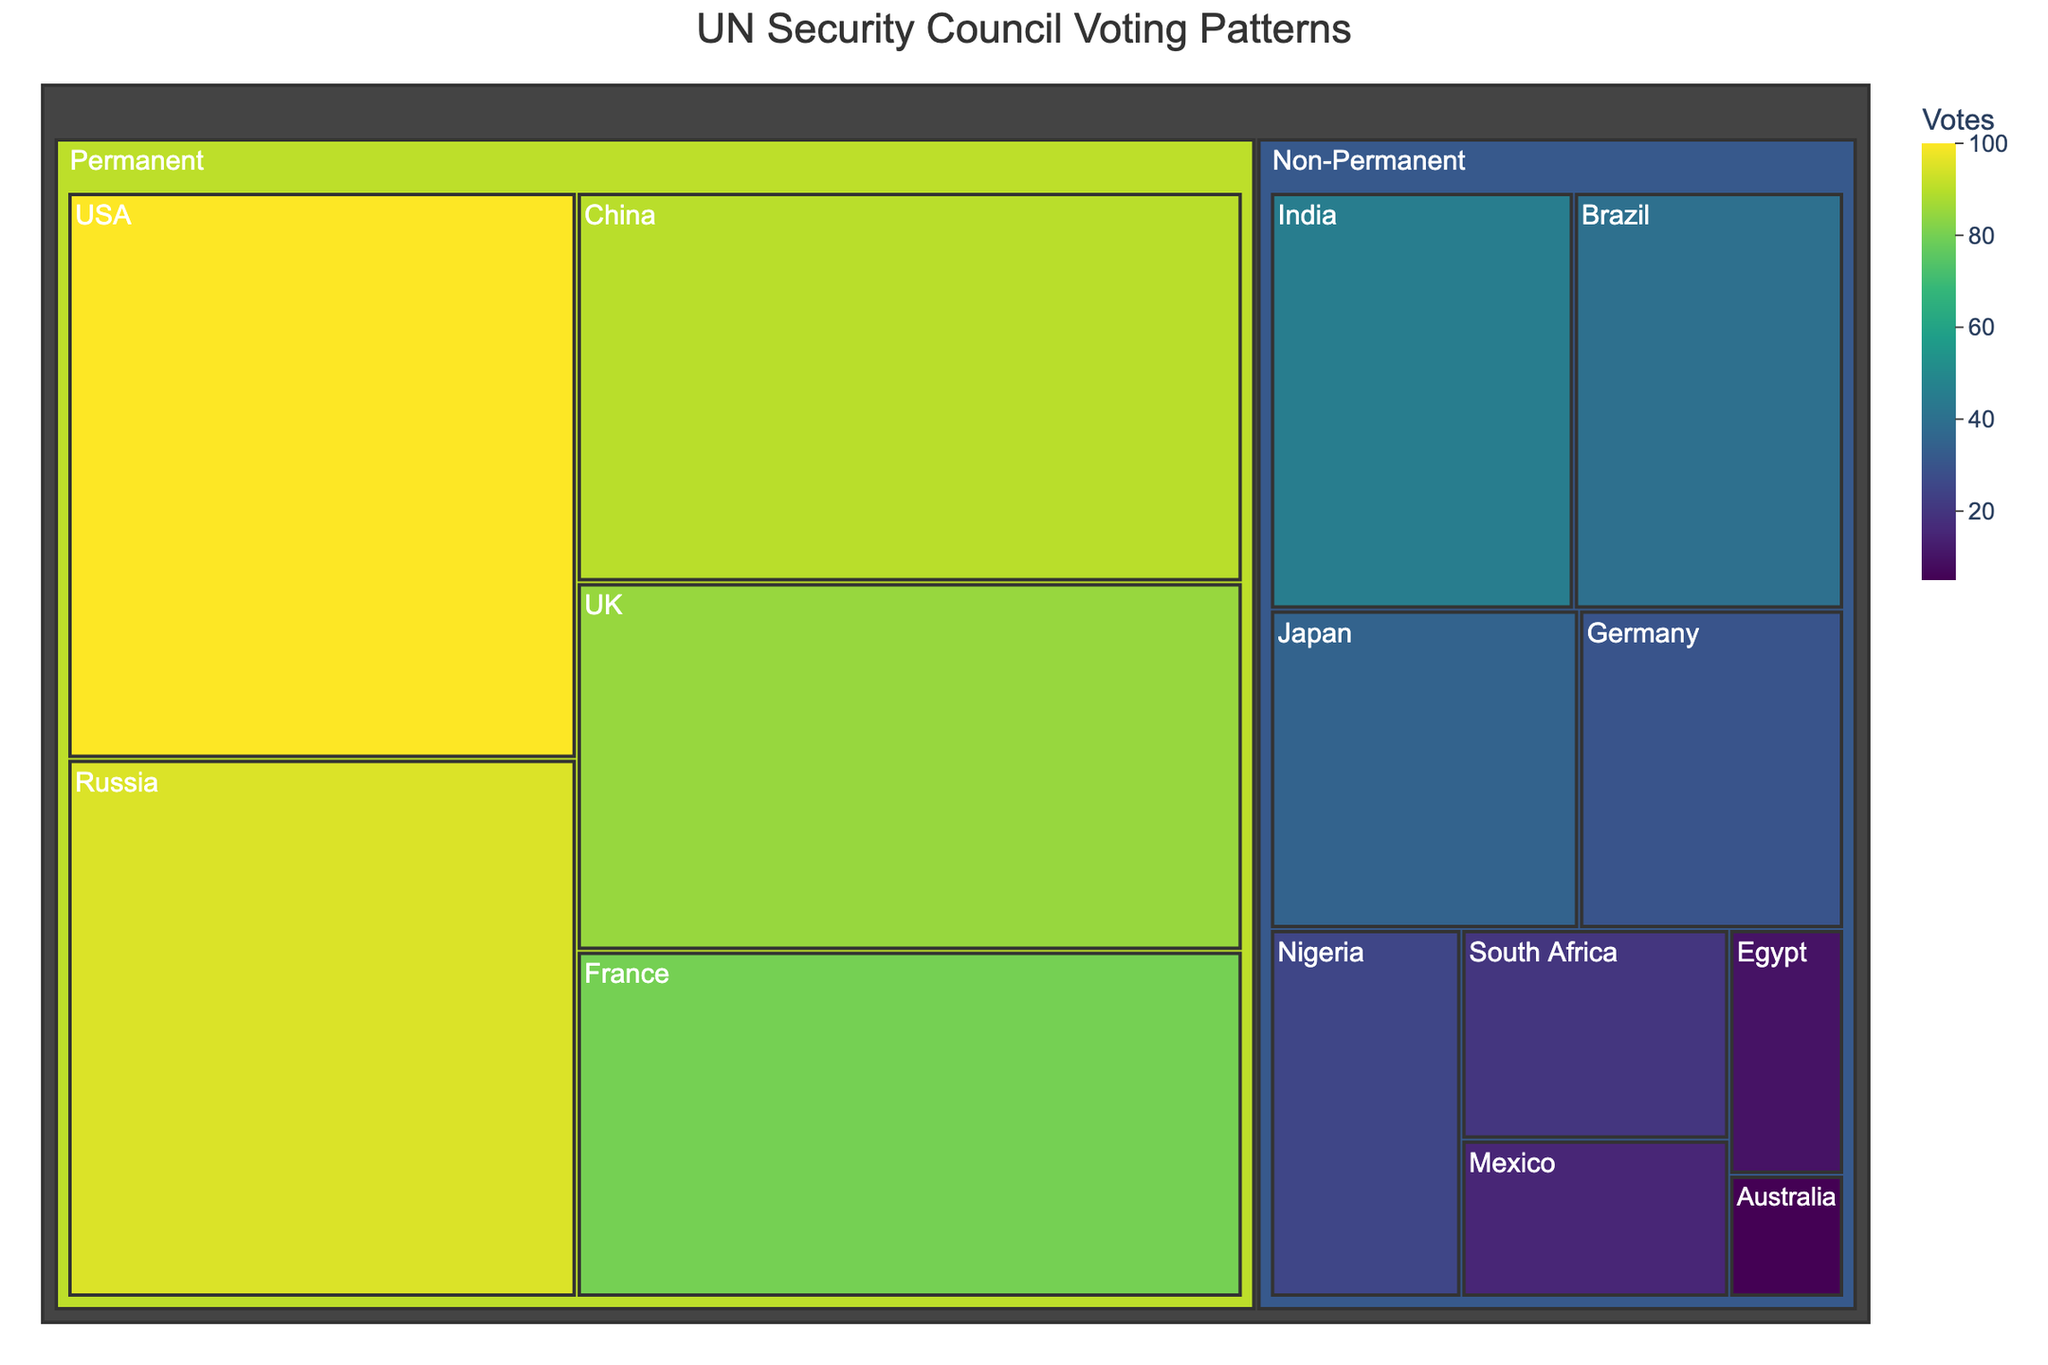What's the title of the treemap? The title is usually displayed at the top of the figure. Observing the figure, we see the title clearly indicated.
Answer: UN Security Council Voting Patterns Which country has the highest number of votes among the permanent members? In the treemap, permanent members are categorized separately. Among them, looking at the area with the highest value, we see that the USA stands out due to its larger size and darker color, indicating a higher number of votes.
Answer: USA What's the total number of votes for non-permanent members? To find the total, we sum the votes of all non-permanent members: India (45), Brazil (40), Japan (35), Germany (30), Nigeria (25), South Africa (20), Mexico (15), Egypt (10), Australia (5). Summing these gives: 45 + 40 + 35 + 30 + 25 + 20 + 15 + 10 + 5.
Answer: 225 How do the total votes of permanent members compare to non-permanent members? We sum the votes for both groups. Permanent: USA (100), Russia (95), China (90), UK (85), France (80): 100 + 95 + 90 + 85 + 80 = 450. Non-permanent is previously calculated as 225. Comparing both: 450 vs. 225.
Answer: Permanent members have twice as many votes as Non-permanent members Which country has the fewest votes among the non-permanent members? In the treemap, we look at the smallest box within the Non-Permanent category. The smallest area with the lightest color corresponds to Australia.
Answer: Australia What's the combined votes of the top two permanent members? The top two permanent members by votes are the USA and Russia. Summing their votes: 100 (USA) + 95 (Russia).
Answer: 195 How many non-permanent members have fewer votes than the country with the least votes among the permanent members? France has the least votes among permanent members with 80 votes. We need to count how many non-permanent members have less than 80 votes. All non-permanent members (India, Brazil, Japan, Germany, Nigeria, South Africa, Mexico, Egypt, Australia) have fewer votes: 9 members.
Answer: 9 Which country has a very close number of votes to China? China has 90 votes. Looking for similar values, the UK has 85 votes which is close.
Answer: UK What is the color scale used in the treemap to indicate votes? The color scale can be identified by examining the legend or observing the gradient change. The specified scale in the treemap is "Viridis".
Answer: Viridis 